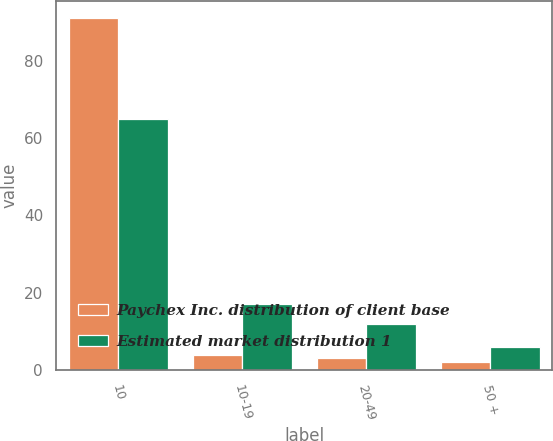<chart> <loc_0><loc_0><loc_500><loc_500><stacked_bar_chart><ecel><fcel>10<fcel>10-19<fcel>20-49<fcel>50 +<nl><fcel>Paychex Inc. distribution of client base<fcel>91<fcel>4<fcel>3<fcel>2<nl><fcel>Estimated market distribution 1<fcel>65<fcel>17<fcel>12<fcel>6<nl></chart> 